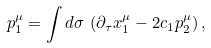<formula> <loc_0><loc_0><loc_500><loc_500>p _ { 1 } ^ { \mu } = \int d \sigma \, \left ( \partial _ { \tau } x _ { 1 } ^ { \mu } - 2 c _ { 1 } p _ { 2 } ^ { \mu } \right ) ,</formula> 